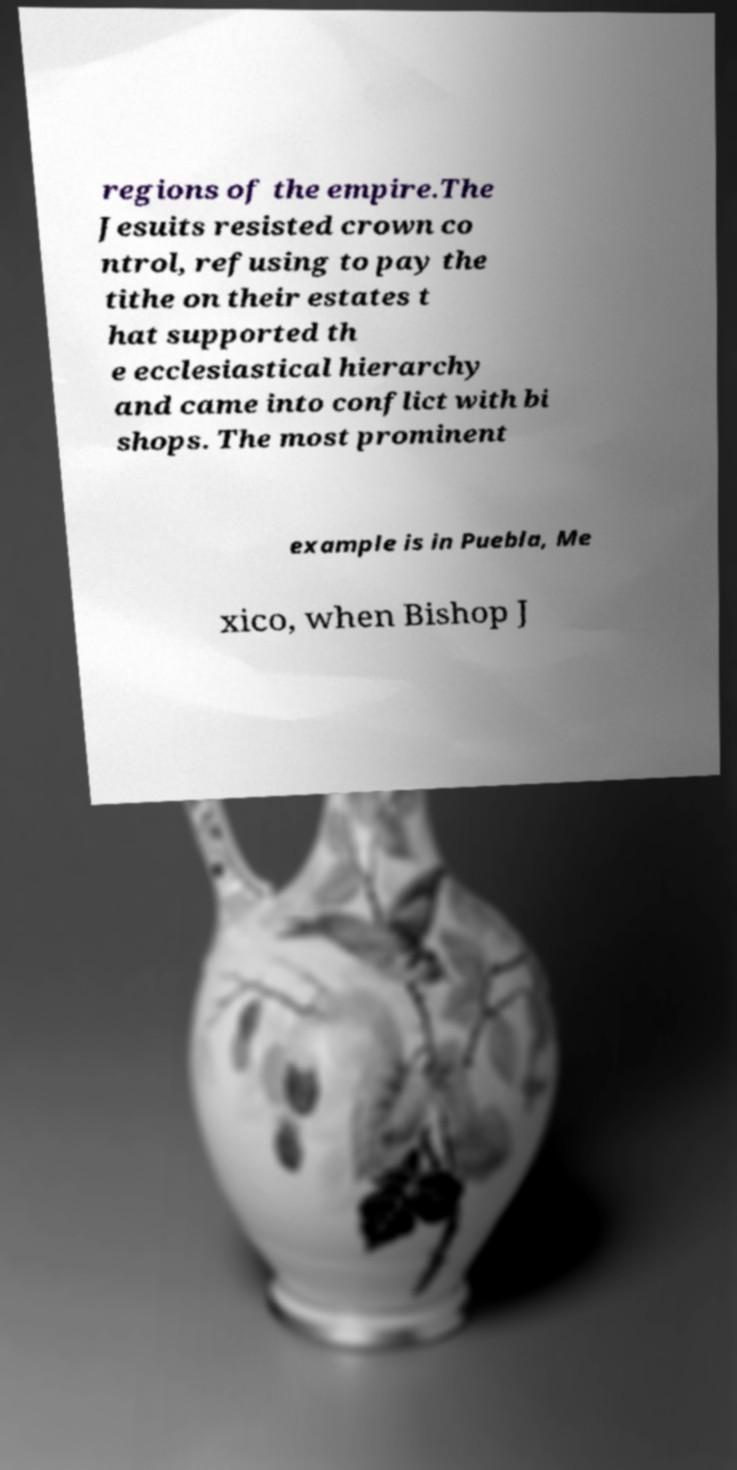Please identify and transcribe the text found in this image. regions of the empire.The Jesuits resisted crown co ntrol, refusing to pay the tithe on their estates t hat supported th e ecclesiastical hierarchy and came into conflict with bi shops. The most prominent example is in Puebla, Me xico, when Bishop J 